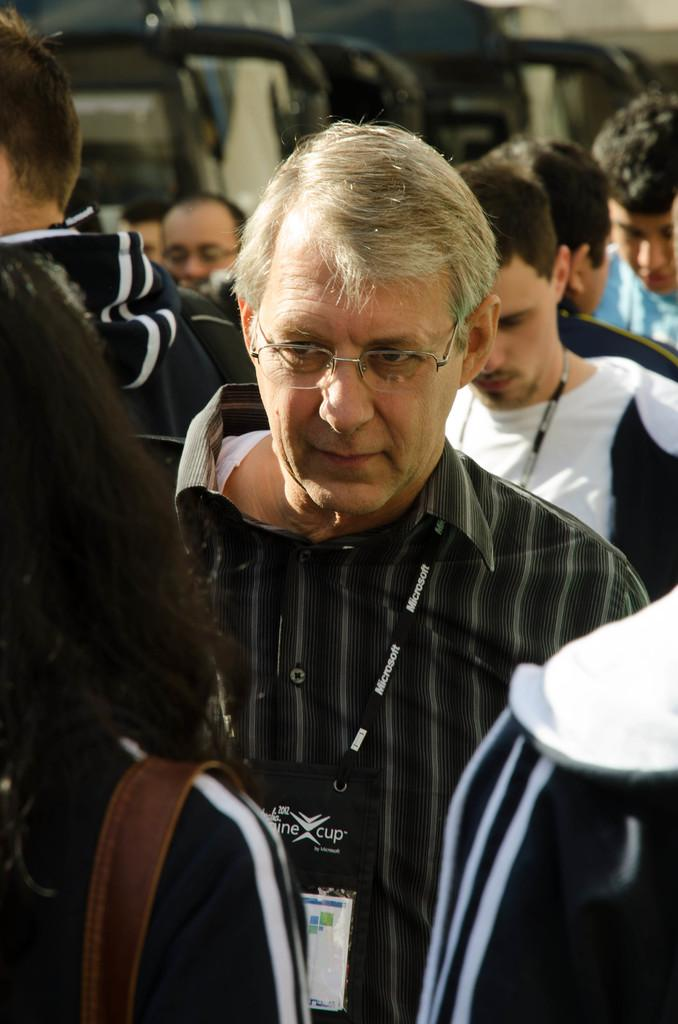How many people are in the image? There are people in the image. Can you describe any specific details about the people in the image? The first two men are wearing Microsoft ID cards. How much money is being exchanged between the people in the image? There is no indication of money being exchanged in the image. Can you describe the voice of the person in the image? The image is a still photograph, so there is no sound or voice present. 